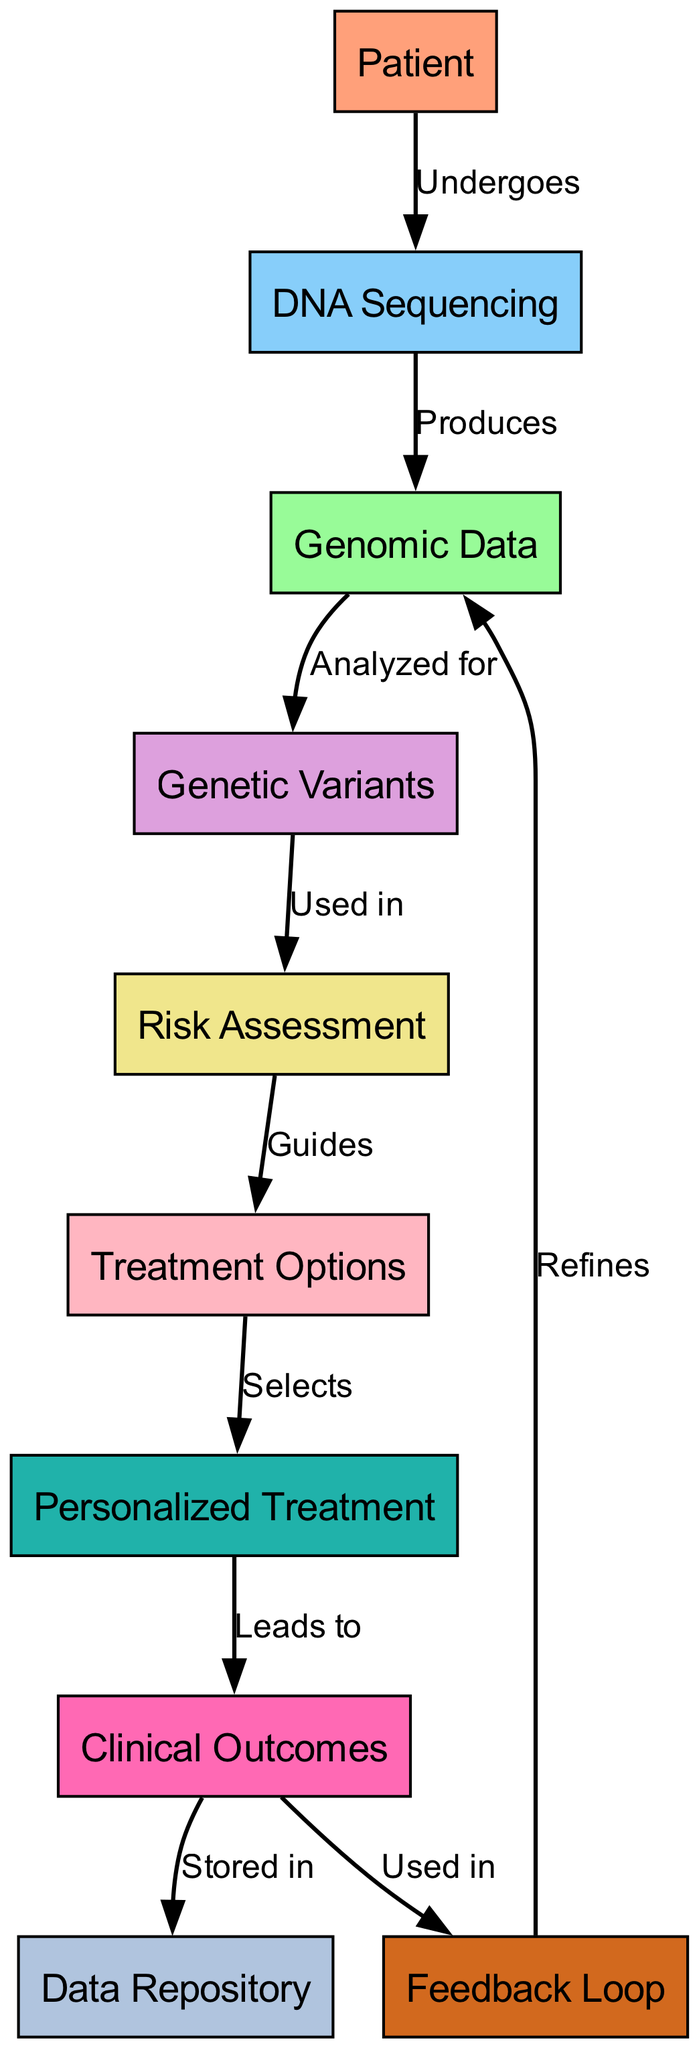What is the first step for the patient? The diagram indicates that the patient undergoes DNA sequencing, which is the first action in the personalized treatment pathway.
Answer: DNA Sequencing How many total nodes are in the diagram? By counting all the unique labeled nodes in the diagram, there are ten nodes listed.
Answer: 10 What leads to clinical outcomes? The diagram shows that personalized treatment leads to clinical outcomes, indicating the outcome of the treatment pathway.
Answer: Personalized Treatment Which node is used in risk assessment? The diagram specifies that genetic variants are used in the risk assessment process, indicating an essential part of evaluating patient risks.
Answer: Genetic Variants What process is initiated from clinical outcomes? The diagram illustrates that clinical outcomes are stored in a data repository, indicating the next step in the information flow following outcomes.
Answer: Data Repository What guides the treatment options? The diagram clearly shows that risk assessment guides the treatment options, indicating that risks inform the selection of potential treatments.
Answer: Risk Assessment What refines the genomic data? The feedback loop is indicated as refining genomic data, suggesting a cyclical process of improvement based on outcomes and new insights.
Answer: Feedback Loop What are the two final results shown in the diagram? The diagram highlights that both the data repository and the feedback loop are the last two components in the flow, serving to store information and improve data quality, respectively.
Answer: Data Repository and Feedback Loop Which two nodes are related by the "selects" relationship? According to the diagram, the treatment options select personalized treatment, indicating a direct choice based on the available treatment paths.
Answer: Treatment Options and Personalized Treatment What is produced by DNA sequencing? The diagram specifies that DNA sequencing produces genomic data, indicating the output of initial genomic analysis.
Answer: Genomic Data 